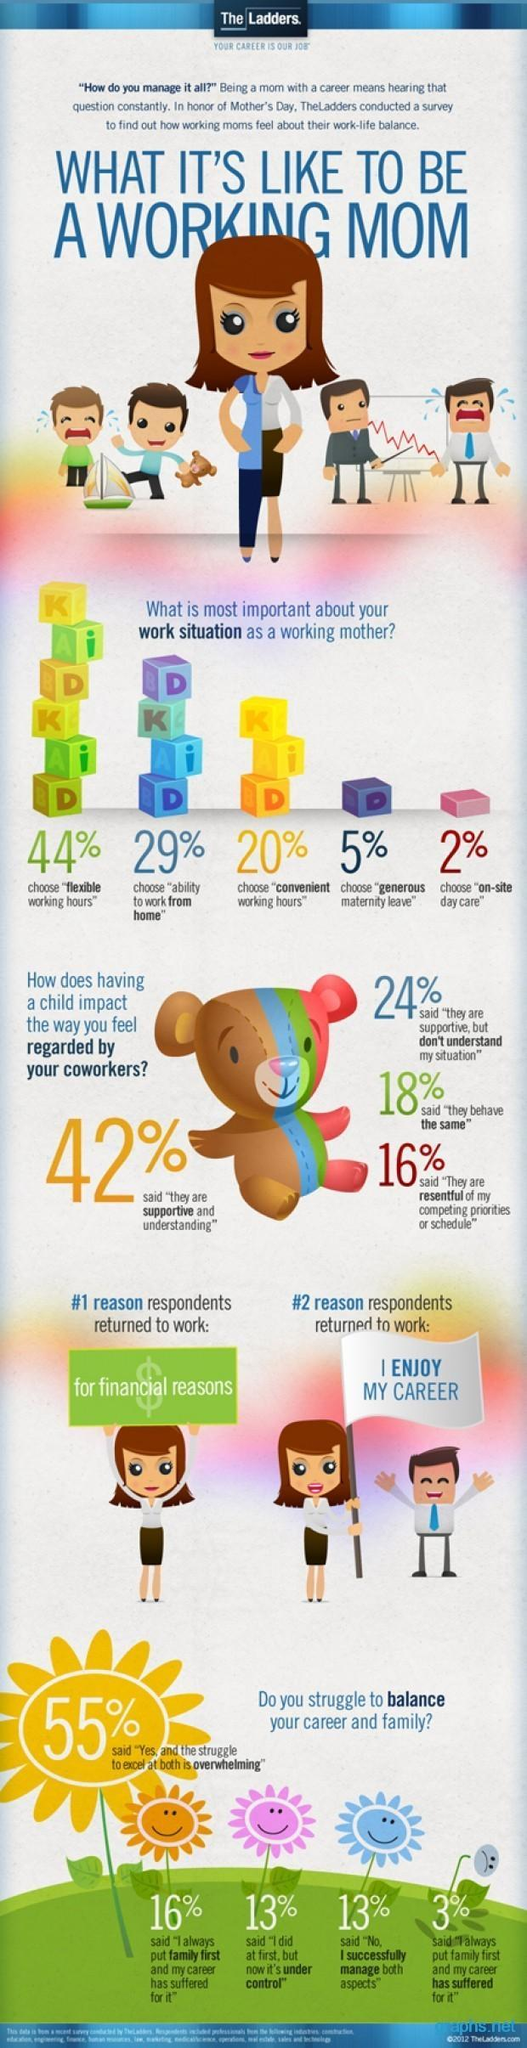What percentage of respondents feel their career has suffered for putting family first?
Answer the question with a short phrase. 16%, 3% What is the total percentage of respondents who choose to have a generous maternity leave and on-site day care? 7% What percentage of moms choose to work from home, 44%, 29%, or 20%? 29% What percentage of colleagues are displeased with family priorities that occur after child birth, 46%, 18%, or 16%? 16% What is the difference in percentage of women who struggle to manage career and family and those who excel at both? 42% 